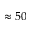<formula> <loc_0><loc_0><loc_500><loc_500>\approx 5 0</formula> 